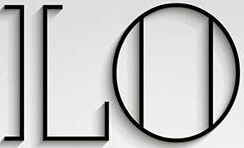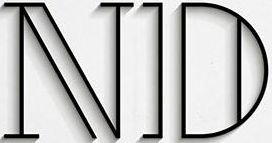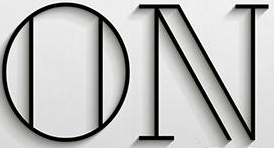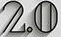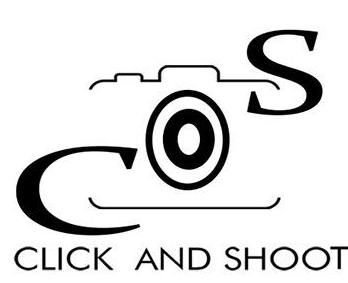Transcribe the words shown in these images in order, separated by a semicolon. LO; ND; ON; 2.0; COS 